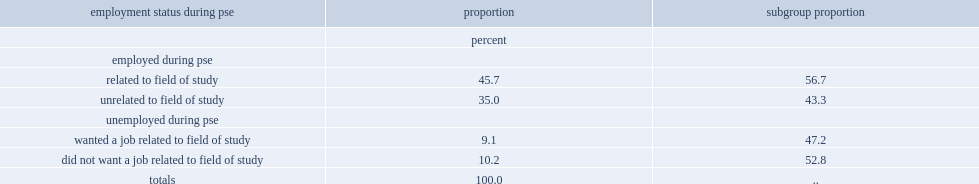What was the percentage of graduates between 2012 and 2016 who had a job at some point during their post-secondary education? 80.7. What was the percentage of graduates who had a job related to their field of study at some point during their pse. 45.7. What were the percentages of graduates that did not have a job during their pse who wanted a job related to their field of study and those not wanting a job related to their field of study? 47.2 52.8. What was the percentage of graduates who did not have a job at any point during their pse and would have liked a job in their field? 9.1. 